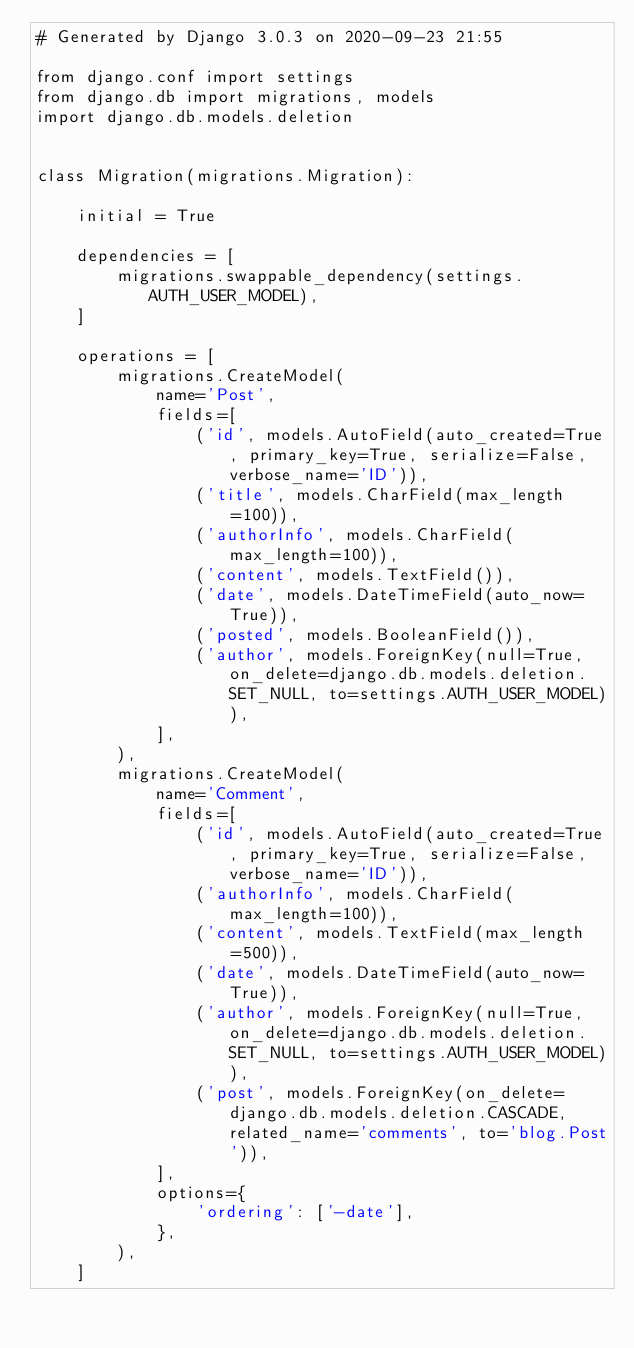<code> <loc_0><loc_0><loc_500><loc_500><_Python_># Generated by Django 3.0.3 on 2020-09-23 21:55

from django.conf import settings
from django.db import migrations, models
import django.db.models.deletion


class Migration(migrations.Migration):

    initial = True

    dependencies = [
        migrations.swappable_dependency(settings.AUTH_USER_MODEL),
    ]

    operations = [
        migrations.CreateModel(
            name='Post',
            fields=[
                ('id', models.AutoField(auto_created=True, primary_key=True, serialize=False, verbose_name='ID')),
                ('title', models.CharField(max_length=100)),
                ('authorInfo', models.CharField(max_length=100)),
                ('content', models.TextField()),
                ('date', models.DateTimeField(auto_now=True)),
                ('posted', models.BooleanField()),
                ('author', models.ForeignKey(null=True, on_delete=django.db.models.deletion.SET_NULL, to=settings.AUTH_USER_MODEL)),
            ],
        ),
        migrations.CreateModel(
            name='Comment',
            fields=[
                ('id', models.AutoField(auto_created=True, primary_key=True, serialize=False, verbose_name='ID')),
                ('authorInfo', models.CharField(max_length=100)),
                ('content', models.TextField(max_length=500)),
                ('date', models.DateTimeField(auto_now=True)),
                ('author', models.ForeignKey(null=True, on_delete=django.db.models.deletion.SET_NULL, to=settings.AUTH_USER_MODEL)),
                ('post', models.ForeignKey(on_delete=django.db.models.deletion.CASCADE, related_name='comments', to='blog.Post')),
            ],
            options={
                'ordering': ['-date'],
            },
        ),
    ]
</code> 